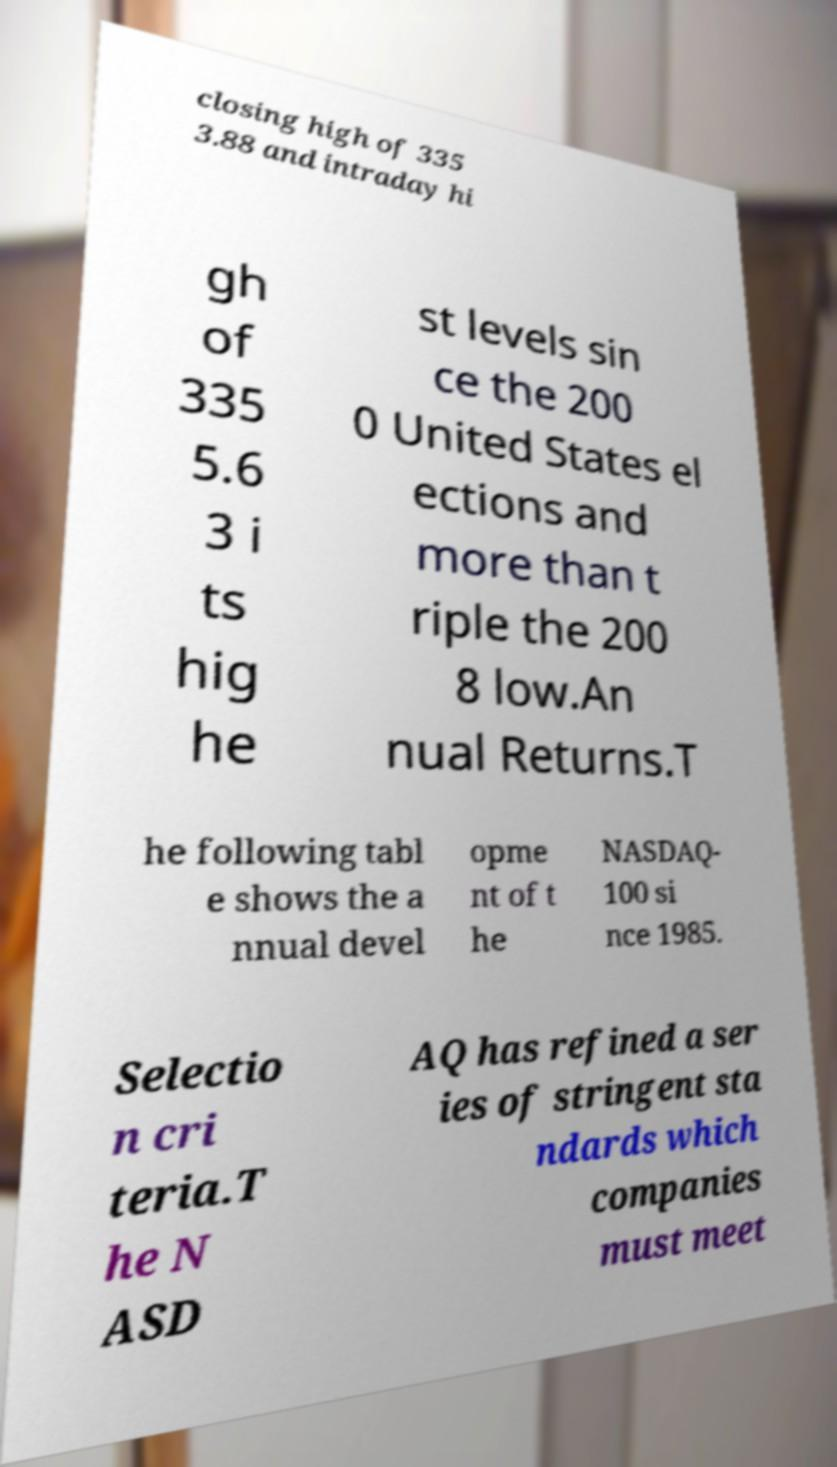There's text embedded in this image that I need extracted. Can you transcribe it verbatim? closing high of 335 3.88 and intraday hi gh of 335 5.6 3 i ts hig he st levels sin ce the 200 0 United States el ections and more than t riple the 200 8 low.An nual Returns.T he following tabl e shows the a nnual devel opme nt of t he NASDAQ- 100 si nce 1985. Selectio n cri teria.T he N ASD AQ has refined a ser ies of stringent sta ndards which companies must meet 